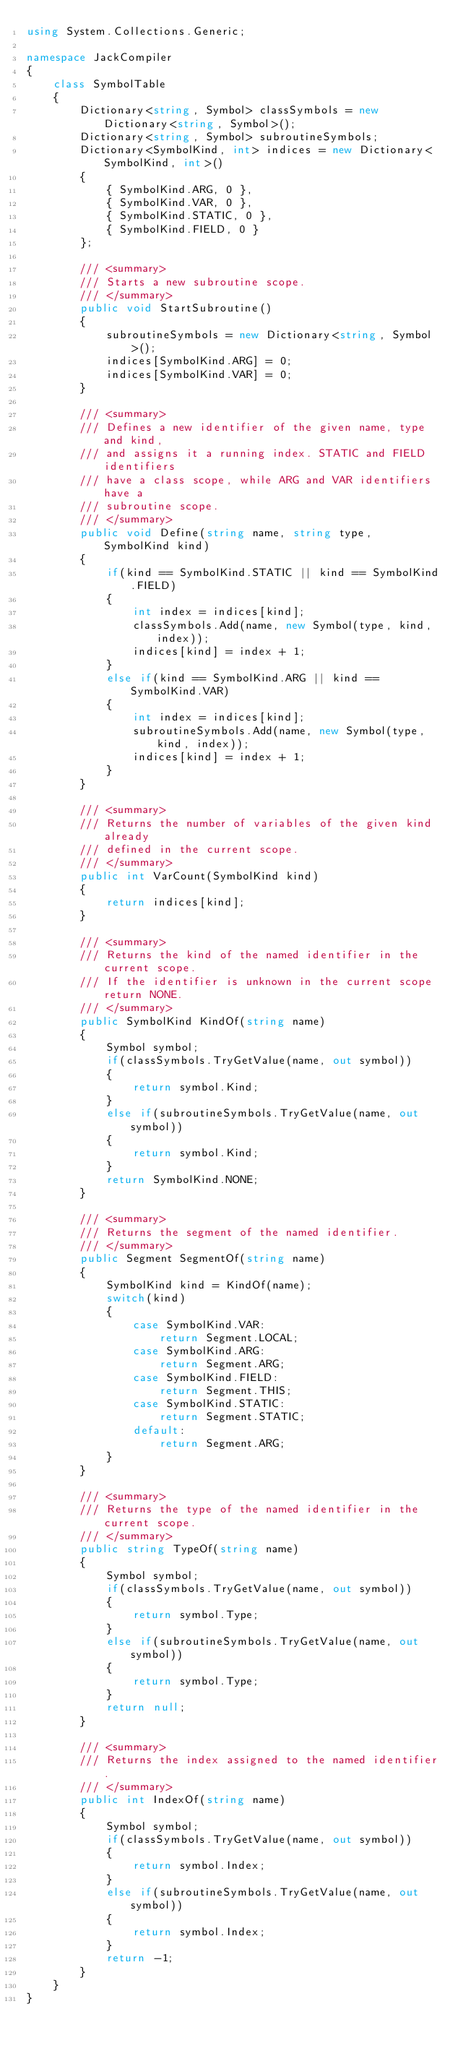Convert code to text. <code><loc_0><loc_0><loc_500><loc_500><_C#_>using System.Collections.Generic;

namespace JackCompiler
{
    class SymbolTable
    {
        Dictionary<string, Symbol> classSymbols = new Dictionary<string, Symbol>();
        Dictionary<string, Symbol> subroutineSymbols;
        Dictionary<SymbolKind, int> indices = new Dictionary<SymbolKind, int>()
        {
            { SymbolKind.ARG, 0 },
            { SymbolKind.VAR, 0 },
            { SymbolKind.STATIC, 0 },
            { SymbolKind.FIELD, 0 }
        };

        /// <summary>
        /// Starts a new subroutine scope.
        /// </summary>
        public void StartSubroutine()
        {
            subroutineSymbols = new Dictionary<string, Symbol>();
            indices[SymbolKind.ARG] = 0;
            indices[SymbolKind.VAR] = 0;
        }

        /// <summary>
        /// Defines a new identifier of the given name, type and kind,
        /// and assigns it a running index. STATIC and FIELD identifiers
        /// have a class scope, while ARG and VAR identifiers have a
        /// subroutine scope.
        /// </summary>
        public void Define(string name, string type, SymbolKind kind)
        {
            if(kind == SymbolKind.STATIC || kind == SymbolKind.FIELD)
            {
                int index = indices[kind];
                classSymbols.Add(name, new Symbol(type, kind, index));
                indices[kind] = index + 1;
            }
            else if(kind == SymbolKind.ARG || kind == SymbolKind.VAR)
            {
                int index = indices[kind];
                subroutineSymbols.Add(name, new Symbol(type, kind, index));
                indices[kind] = index + 1;
            }
        }

        /// <summary>
        /// Returns the number of variables of the given kind already
        /// defined in the current scope.
        /// </summary>
        public int VarCount(SymbolKind kind)
        {
            return indices[kind];
        }

        /// <summary>
        /// Returns the kind of the named identifier in the current scope.
        /// If the identifier is unknown in the current scope return NONE.
        /// </summary>
        public SymbolKind KindOf(string name)
        {
            Symbol symbol;
            if(classSymbols.TryGetValue(name, out symbol))
            {
                return symbol.Kind;
            }
            else if(subroutineSymbols.TryGetValue(name, out symbol))
            {
                return symbol.Kind;
            }
            return SymbolKind.NONE;
        }

        /// <summary>
        /// Returns the segment of the named identifier.
        /// </summary>
        public Segment SegmentOf(string name)
        {
            SymbolKind kind = KindOf(name);
            switch(kind)
            {
                case SymbolKind.VAR:
                    return Segment.LOCAL;
                case SymbolKind.ARG:
                    return Segment.ARG;
                case SymbolKind.FIELD:
                    return Segment.THIS;
                case SymbolKind.STATIC:
                    return Segment.STATIC;
                default:
                    return Segment.ARG;
            }
        }

        /// <summary>
        /// Returns the type of the named identifier in the current scope.
        /// </summary>
        public string TypeOf(string name)
        {
            Symbol symbol;
            if(classSymbols.TryGetValue(name, out symbol))
            {
                return symbol.Type;
            }
            else if(subroutineSymbols.TryGetValue(name, out symbol))
            {
                return symbol.Type;
            }
            return null;
        }

        /// <summary>
        /// Returns the index assigned to the named identifier.
        /// </summary>
        public int IndexOf(string name)
        {
            Symbol symbol;
            if(classSymbols.TryGetValue(name, out symbol))
            {
                return symbol.Index;
            }
            else if(subroutineSymbols.TryGetValue(name, out symbol))
            {
                return symbol.Index;
            }
            return -1;
        }
    }
}</code> 